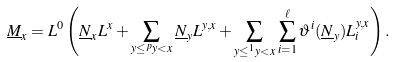Convert formula to latex. <formula><loc_0><loc_0><loc_500><loc_500>\underline { M } _ { x } = L ^ { 0 } \left ( \underline { N } _ { x } L ^ { x } + \sum _ { y \leq ^ { p } y < x } \underline { N } _ { y } L ^ { y , x } + \sum _ { y \leq ^ { 1 } y < x } \sum _ { i = 1 } ^ { \ell } \vartheta ^ { i } ( \underline { N } _ { y } ) L _ { i } ^ { y , x } \right ) .</formula> 